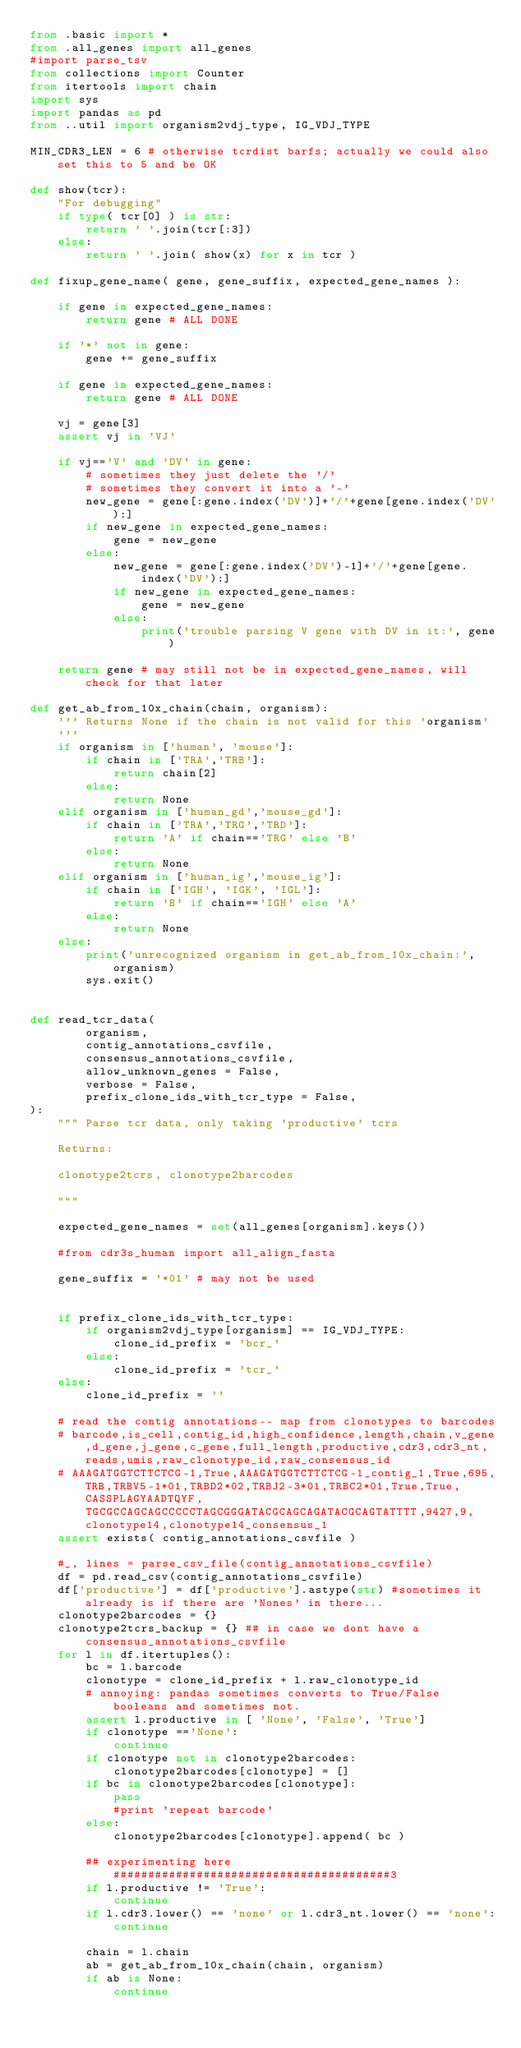<code> <loc_0><loc_0><loc_500><loc_500><_Python_>from .basic import *
from .all_genes import all_genes
#import parse_tsv
from collections import Counter
from itertools import chain
import sys
import pandas as pd
from ..util import organism2vdj_type, IG_VDJ_TYPE

MIN_CDR3_LEN = 6 # otherwise tcrdist barfs; actually we could also set this to 5 and be OK

def show(tcr):
    "For debugging"
    if type( tcr[0] ) is str:
        return ' '.join(tcr[:3])
    else:
        return ' '.join( show(x) for x in tcr )

def fixup_gene_name( gene, gene_suffix, expected_gene_names ):

    if gene in expected_gene_names:
        return gene # ALL DONE

    if '*' not in gene:
        gene += gene_suffix

    if gene in expected_gene_names:
        return gene # ALL DONE

    vj = gene[3]
    assert vj in 'VJ'

    if vj=='V' and 'DV' in gene:
        # sometimes they just delete the '/'
        # sometimes they convert it into a '-'
        new_gene = gene[:gene.index('DV')]+'/'+gene[gene.index('DV'):]
        if new_gene in expected_gene_names:
            gene = new_gene
        else:
            new_gene = gene[:gene.index('DV')-1]+'/'+gene[gene.index('DV'):]
            if new_gene in expected_gene_names:
                gene = new_gene
            else:
                print('trouble parsing V gene with DV in it:', gene)

    return gene # may still not be in expected_gene_names, will check for that later

def get_ab_from_10x_chain(chain, organism):
    ''' Returns None if the chain is not valid for this 'organism'
    '''
    if organism in ['human', 'mouse']:
        if chain in ['TRA','TRB']:
            return chain[2]
        else:
            return None
    elif organism in ['human_gd','mouse_gd']:
        if chain in ['TRA','TRG','TRD']:
            return 'A' if chain=='TRG' else 'B'
        else:
            return None
    elif organism in ['human_ig','mouse_ig']:
        if chain in ['IGH', 'IGK', 'IGL']:
            return 'B' if chain=='IGH' else 'A'
        else:
            return None
    else:
        print('unrecognized organism in get_ab_from_10x_chain:', organism)
        sys.exit()


def read_tcr_data(
        organism,
        contig_annotations_csvfile,
        consensus_annotations_csvfile,
        allow_unknown_genes = False,
        verbose = False,
        prefix_clone_ids_with_tcr_type = False,
):
    """ Parse tcr data, only taking 'productive' tcrs

    Returns:

    clonotype2tcrs, clonotype2barcodes

    """

    expected_gene_names = set(all_genes[organism].keys())

    #from cdr3s_human import all_align_fasta

    gene_suffix = '*01' # may not be used


    if prefix_clone_ids_with_tcr_type:
        if organism2vdj_type[organism] == IG_VDJ_TYPE:
            clone_id_prefix = 'bcr_'
        else:
            clone_id_prefix = 'tcr_'
    else:
        clone_id_prefix = ''

    # read the contig annotations-- map from clonotypes to barcodes
    # barcode,is_cell,contig_id,high_confidence,length,chain,v_gene,d_gene,j_gene,c_gene,full_length,productive,cdr3,cdr3_nt,reads,umis,raw_clonotype_id,raw_consensus_id
    # AAAGATGGTCTTCTCG-1,True,AAAGATGGTCTTCTCG-1_contig_1,True,695,TRB,TRBV5-1*01,TRBD2*02,TRBJ2-3*01,TRBC2*01,True,True,CASSPLAGYAADTQYF,TGCGCCAGCAGCCCCCTAGCGGGATACGCAGCAGATACGCAGTATTTT,9427,9,clonotype14,clonotype14_consensus_1
    assert exists( contig_annotations_csvfile )

    #_, lines = parse_csv_file(contig_annotations_csvfile)
    df = pd.read_csv(contig_annotations_csvfile)
    df['productive'] = df['productive'].astype(str) #sometimes it already is if there are 'Nones' in there...
    clonotype2barcodes = {}
    clonotype2tcrs_backup = {} ## in case we dont have a consensus_annotations_csvfile
    for l in df.itertuples():
        bc = l.barcode
        clonotype = clone_id_prefix + l.raw_clonotype_id
        # annoying: pandas sometimes converts to True/False booleans and sometimes not.
        assert l.productive in [ 'None', 'False', 'True']
        if clonotype =='None':
            continue
        if clonotype not in clonotype2barcodes:
            clonotype2barcodes[clonotype] = []
        if bc in clonotype2barcodes[clonotype]:
            pass
            #print 'repeat barcode'
        else:
            clonotype2barcodes[clonotype].append( bc )

        ## experimenting here ########################################3
        if l.productive != 'True':
            continue
        if l.cdr3.lower() == 'none' or l.cdr3_nt.lower() == 'none':
            continue

        chain = l.chain
        ab = get_ab_from_10x_chain(chain, organism)
        if ab is None:
            continue</code> 